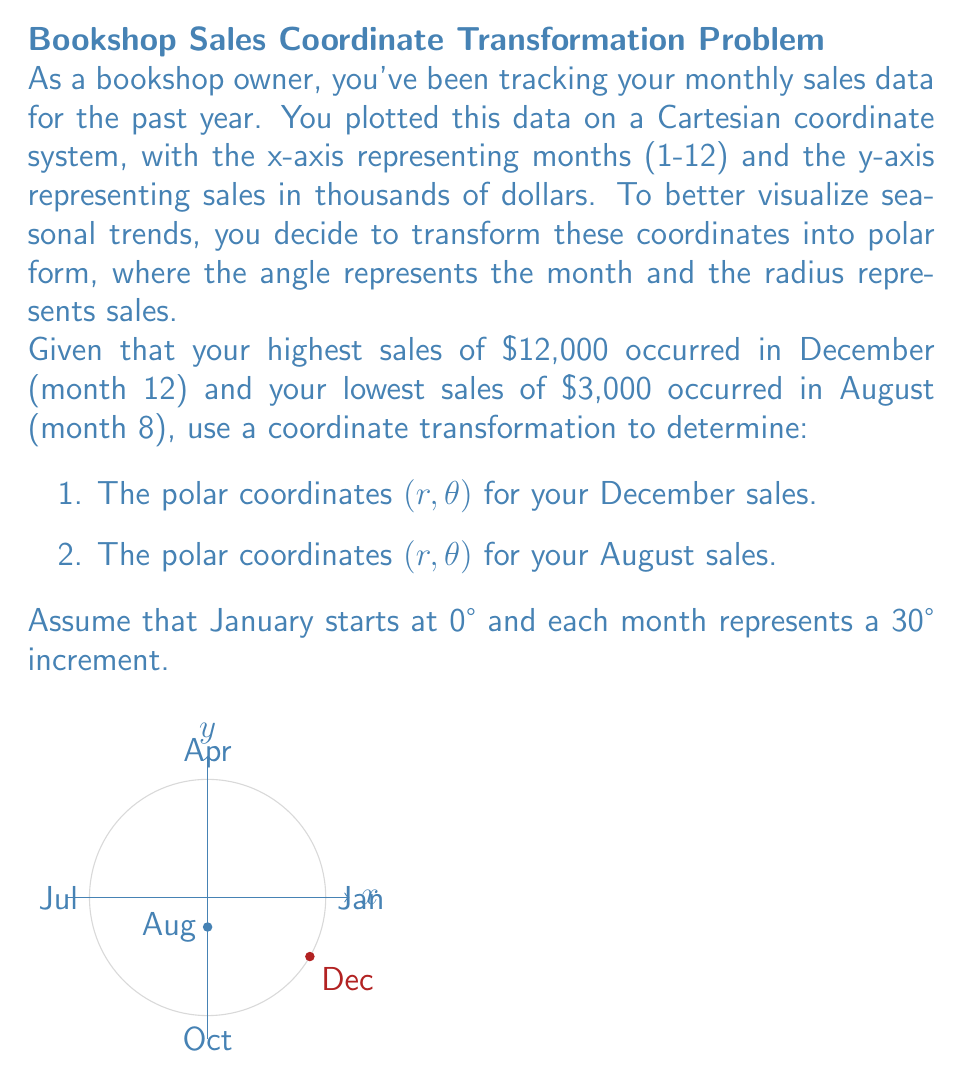Solve this math problem. Let's approach this step-by-step:

1) First, we need to understand the transformation from Cartesian to polar coordinates:
   $r = \sqrt{x^2 + y^2}$
   $\theta = \arctan(\frac{y}{x})$ (adjusted for quadrant)

2) In our case, the x-coordinate represents the month, and the y-coordinate represents sales. We need to transform this to polar coordinates where:
   - $r$ represents sales (in thousands of dollars)
   - $\theta$ represents the month (in degrees)

3) For the angle $\theta$:
   - There are 12 months in a year, so each month represents $\frac{360°}{12} = 30°$
   - December is month 12, so $\theta_{Dec} = (12-1) * 30° = 330°$
   - August is month 8, so $\theta_{Aug} = (8-1) * 30° = 210°$

4) For the radius $r$:
   - December sales: $r_{Dec} = 12$ (representing $12,000)
   - August sales: $r_{Aug} = 3$ (representing $3,000)

5) Therefore, the polar coordinates are:
   - December: $(12, 330°)$
   - August: $(3, 210°)$

6) To express these in proper mathematical notation:
   - December: $(12, \frac{11\pi}{6})$ radians
   - August: $(3, \frac{7\pi}{6})$ radians

This transformation allows you to visualize your sales data in a circular format, making seasonal trends more apparent. High sales months will appear further from the origin, while low sales months will be closer to the origin.
Answer: December: $(12, \frac{11\pi}{6})$, August: $(3, \frac{7\pi}{6})$ 